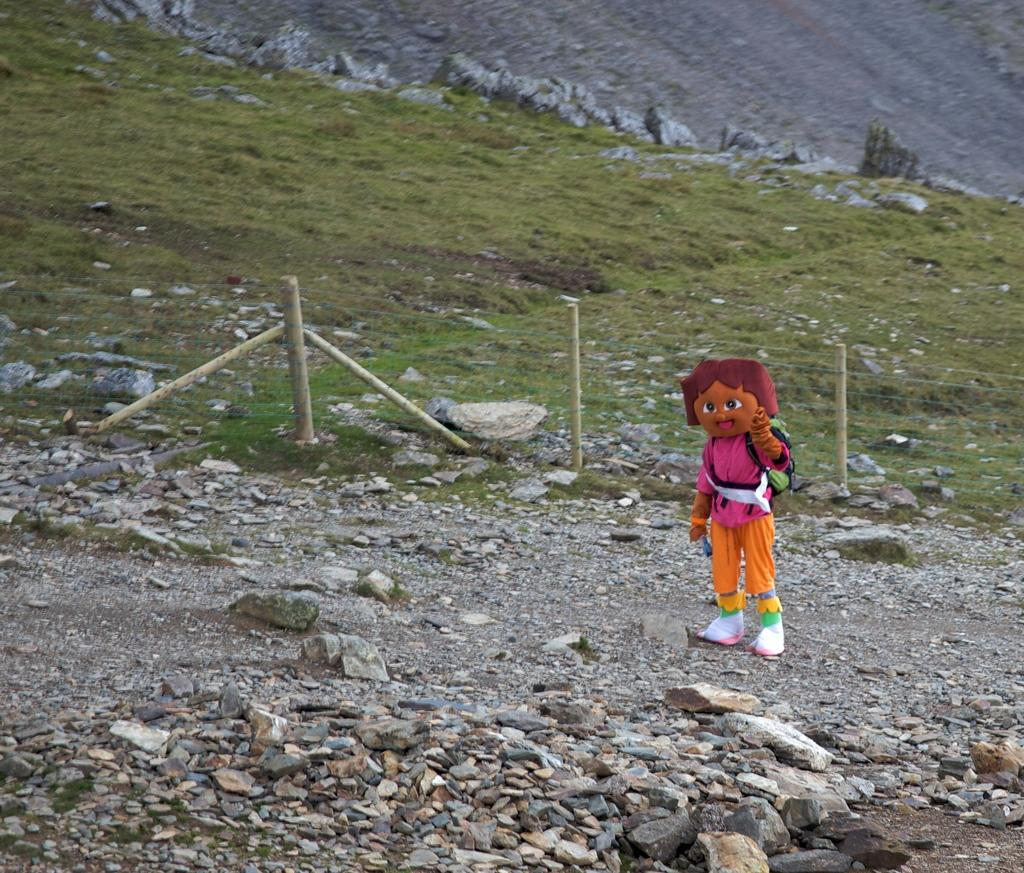What is the person in the image wearing? There is a person in a costume in the image. What type of terrain is visible in the image? There are stones, a wire fence, and grass visible in the image. What can be seen in the background of the image? There is a hill in the background of the image. What type of jar is being used to fulfill the person's desire in the image? There is no jar or desire present in the image; it features a person in a costume and various elements of the terrain and background. 